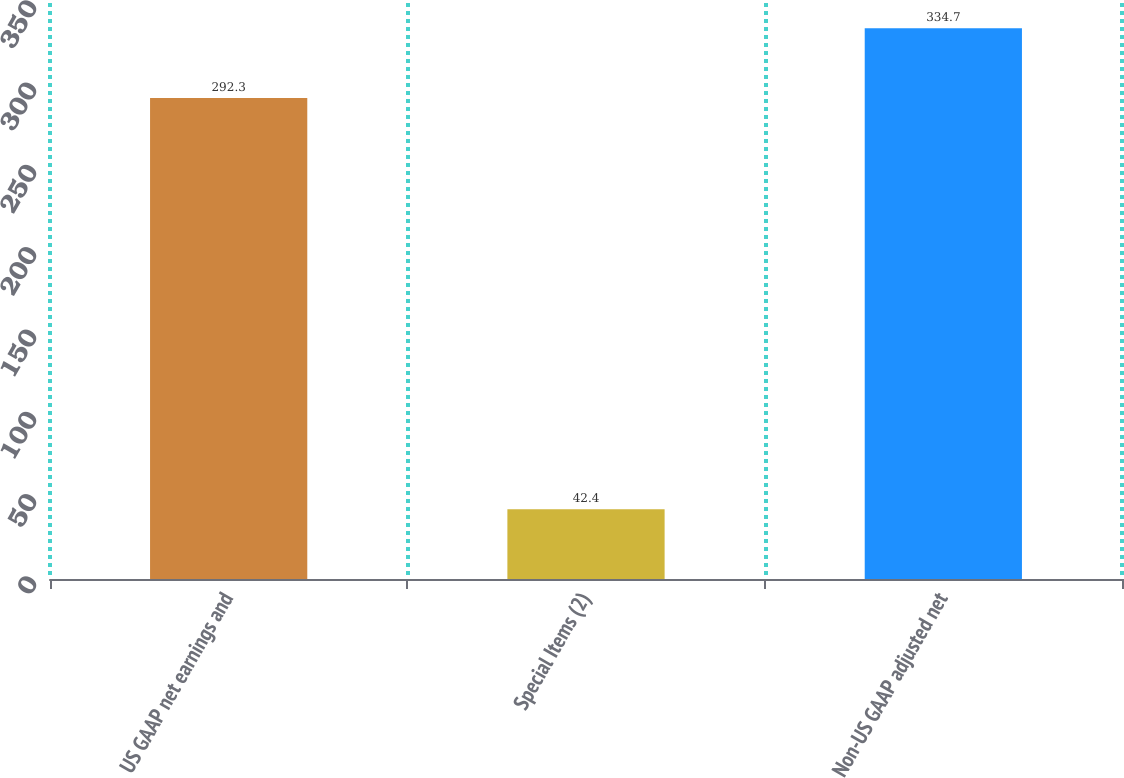<chart> <loc_0><loc_0><loc_500><loc_500><bar_chart><fcel>US GAAP net earnings and<fcel>Special Items (2)<fcel>Non-US GAAP adjusted net<nl><fcel>292.3<fcel>42.4<fcel>334.7<nl></chart> 